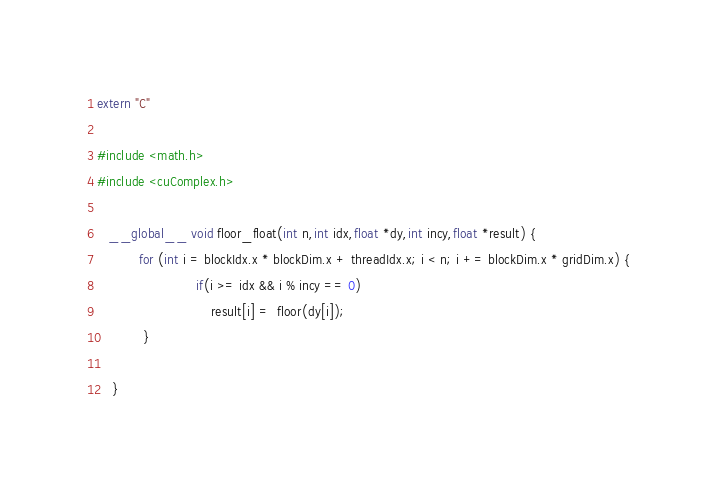Convert code to text. <code><loc_0><loc_0><loc_500><loc_500><_Cuda_>extern "C"

#include <math.h>
#include <cuComplex.h>

   __global__ void floor_float(int n,int idx,float *dy,int incy,float *result) {
           for (int i = blockIdx.x * blockDim.x + threadIdx.x; i < n; i += blockDim.x * gridDim.x) {
                          if(i >= idx && i % incy == 0)
                              result[i] =  floor(dy[i]);
            }

    }</code> 